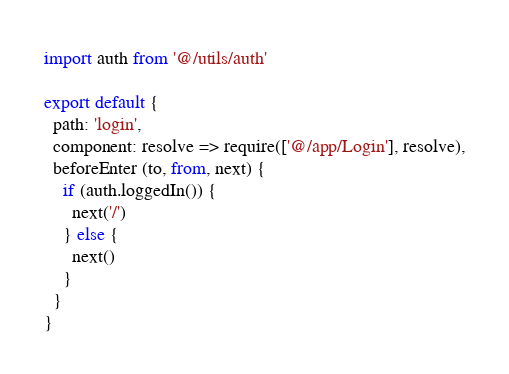Convert code to text. <code><loc_0><loc_0><loc_500><loc_500><_JavaScript_>import auth from '@/utils/auth'

export default {
  path: 'login',
  component: resolve => require(['@/app/Login'], resolve),
  beforeEnter (to, from, next) {
    if (auth.loggedIn()) {
      next('/')
    } else {
      next()
    }
  }
}
</code> 